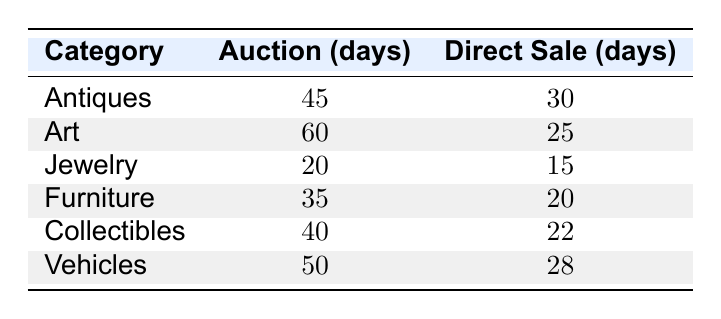What is the average time to sell Jewelry through auction? The table indicates the average time to sell Jewelry via auction is listed as 20 days.
Answer: 20 days Which category takes the longest to sell items through auction? Comparing the Auction times for each category: Antiques (45 days), Art (60 days), Jewelry (20 days), Furniture (35 days), Collectibles (40 days), and Vehicles (50 days). The longest time is Art at 60 days.
Answer: Art What is the difference in average selling time between auction and direct sale for Antiques? The average selling time for Antiques through auction is 45 days, and through direct sale, it is 30 days. The difference is 45 - 30 = 15 days.
Answer: 15 days Is it faster to sell Vehicles through auction or direct sale? For Vehicles, the auction time is 50 days and the direct sale time is 28 days. Since 28 days is less than 50 days, it is faster to sell Vehicles through direct sale.
Answer: Yes What is the average time to sell Collectibles items across both auction and direct sale? Collectibles auction time is 40 days and direct sale time is 22 days. The average is (40 + 22) / 2 = 31 days.
Answer: 31 days Which category has the shortest average time to sell items via direct sale? Reviewing the Direct Sale times: Antiques (30 days), Art (25 days), Jewelry (15 days), Furniture (20 days), Collectibles (22 days), and Vehicles (28 days). The shortest time is Jewelry at 15 days.
Answer: Jewelry How much longer, on average, does it take to sell Furniture via auction compared to direct sale? Auction time for Furniture is 35 days, while direct sale is 20 days. The difference is 35 - 20 = 15 days longer for auction.
Answer: 15 days Does selling through auction generally take longer than selling through direct sale? Comparing all categories in the table, auctions take 45, 60, 20, 35, 40, and 50 days, while direct sales take 30, 25, 15, 20, 22, and 28 days, indicating that auction times are consistently longer than direct sale times.
Answer: Yes What is the total average time to sell all estate items through auction? Summing the auction times: 45 + 60 + 20 + 35 + 40 + 50 = 250 days. There are 6 items, so the average is 250 / 6 ≈ 41.67 days.
Answer: Approximately 41.67 days If a family wants to sell furniture quickly, which method should they choose? The time to sell Furniture via auction is 35 days, while via direct sale it's 20 days, making direct sale the quicker option.
Answer: Direct Sale 